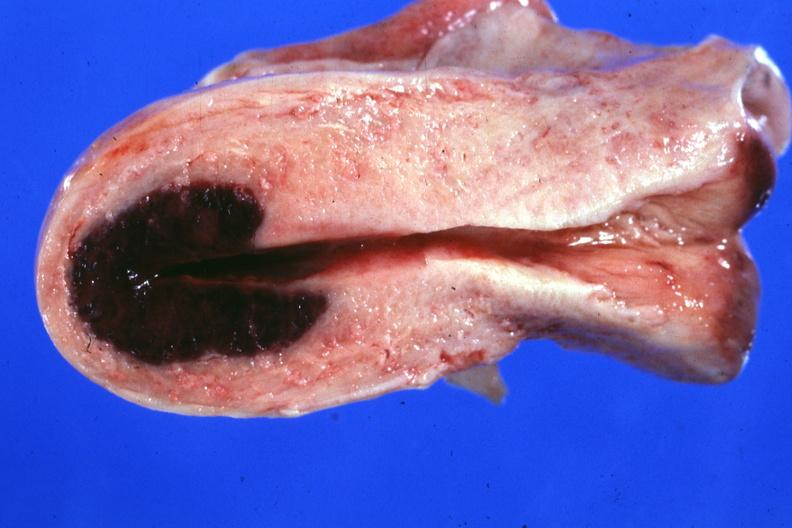s an opened peritoneal cavity cause by fibrous band strangulation present?
Answer the question using a single word or phrase. No 